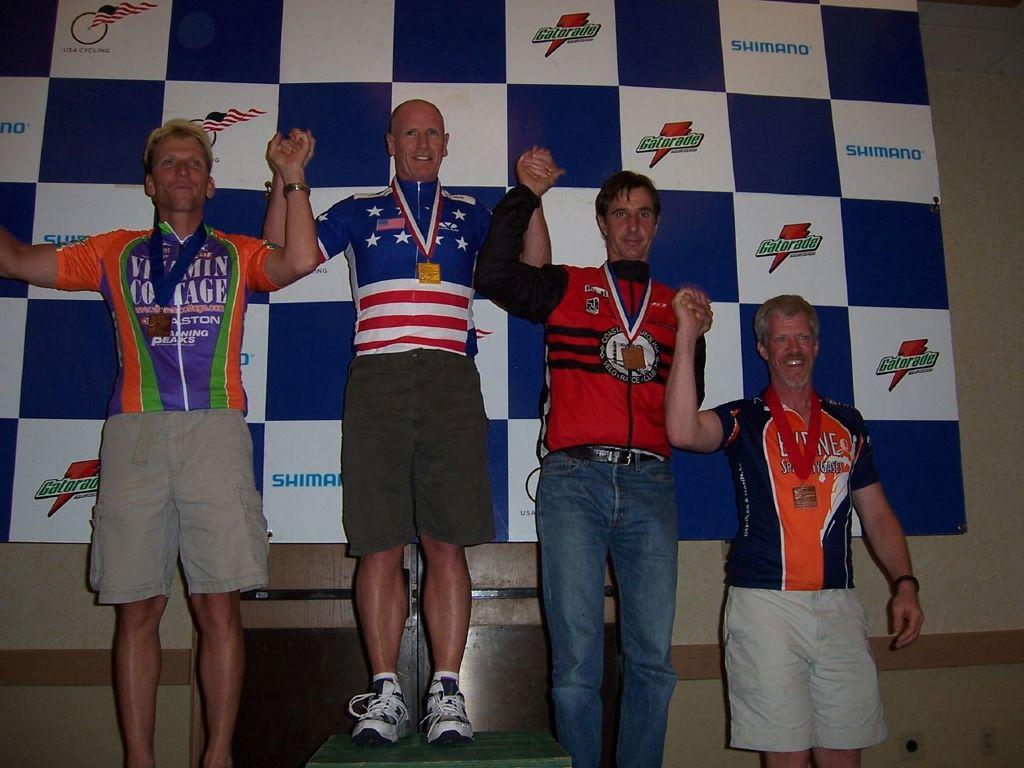<image>
Give a short and clear explanation of the subsequent image. some Olympic winners sponsored by Gatorade in the back of them. 